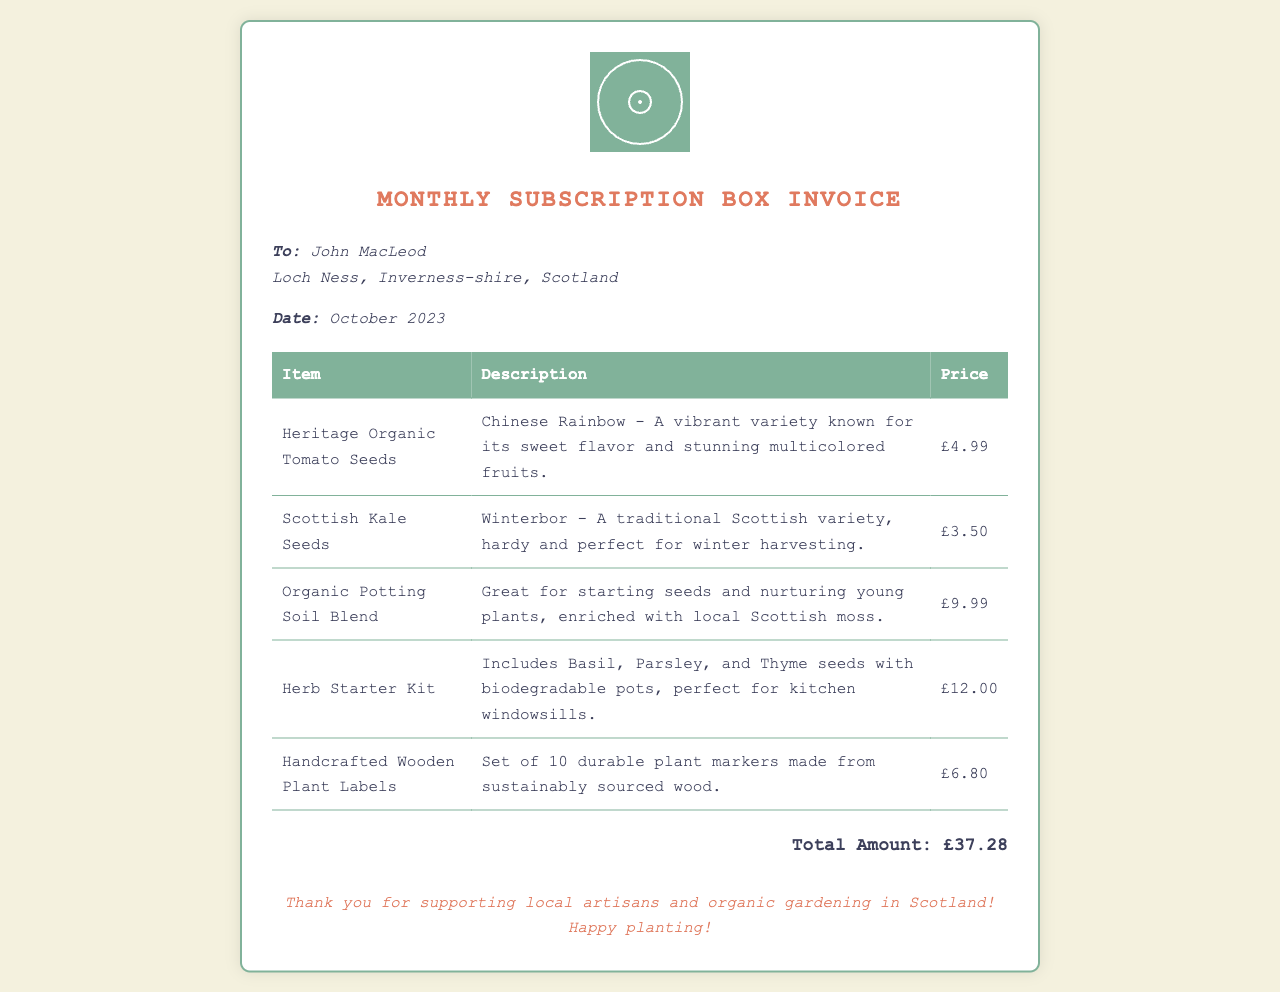What is the total amount due? The total amount is listed at the bottom of the invoice as the sum of all items.
Answer: £37.28 Who is the recipient of the invoice? The invoice specifically mentions John MacLeod as the recipient.
Answer: John MacLeod What is included in the Herb Starter Kit? The description of the Herb Starter Kit details the seeds included in the kit.
Answer: Basil, Parsley, and Thyme seeds What type of soil is listed in the invoice? The invoice provides specific details about the type of potting soil blend included.
Answer: Organic Potting Soil Blend What is the price of the Scottish Kale Seeds? The price for the Scottish Kale Seeds is clearly shown in the document.
Answer: £3.50 How many handcrafted wooden plant labels are provided? The product description specifies the quantity included in the set of plant labels.
Answer: Set of 10 What is the description of the Heritage Organic Tomato Seeds? The document contains a descriptive phrase about this specific seed variety.
Answer: A vibrant variety known for its sweet flavor and stunning multicolored fruits When was the invoice dated? The date of the invoice is mentioned in the document under the recipient's details.
Answer: October 2023 What is the purpose of the invoice? The overall context suggests the intention behind sending the invoice.
Answer: Monthly subscription box for organic seeds and gardening supplies 